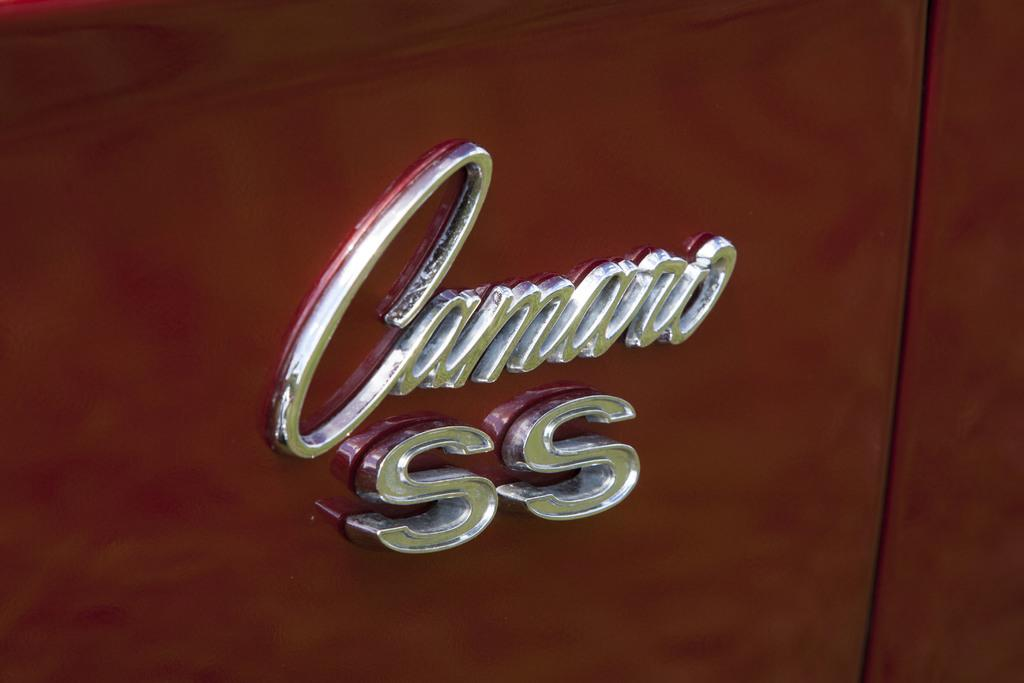What type of object has silver-colored letters on it in the image? The provided facts do not specify the type of object with silver-colored letters. What is the color of the background in the image? The background of the image is brown in color. What type of beef is being stored in the wax drawer in the image? There is no mention of beef or a wax drawer in the provided facts, so this question cannot be answered. 